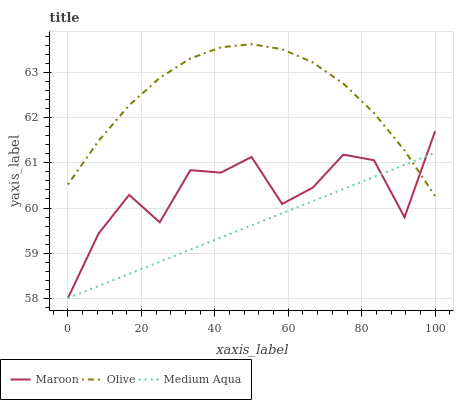Does Medium Aqua have the minimum area under the curve?
Answer yes or no. Yes. Does Olive have the maximum area under the curve?
Answer yes or no. Yes. Does Maroon have the minimum area under the curve?
Answer yes or no. No. Does Maroon have the maximum area under the curve?
Answer yes or no. No. Is Medium Aqua the smoothest?
Answer yes or no. Yes. Is Maroon the roughest?
Answer yes or no. Yes. Is Maroon the smoothest?
Answer yes or no. No. Is Medium Aqua the roughest?
Answer yes or no. No. Does Medium Aqua have the lowest value?
Answer yes or no. Yes. Does Olive have the highest value?
Answer yes or no. Yes. Does Maroon have the highest value?
Answer yes or no. No. Does Olive intersect Maroon?
Answer yes or no. Yes. Is Olive less than Maroon?
Answer yes or no. No. Is Olive greater than Maroon?
Answer yes or no. No. 